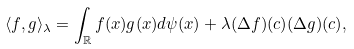Convert formula to latex. <formula><loc_0><loc_0><loc_500><loc_500>\langle f , g \rangle _ { \lambda } = \int _ { \mathbb { R } } f ( x ) g ( x ) d \psi ( x ) + \lambda ( \Delta f ) ( c ) ( \Delta g ) ( c ) ,</formula> 